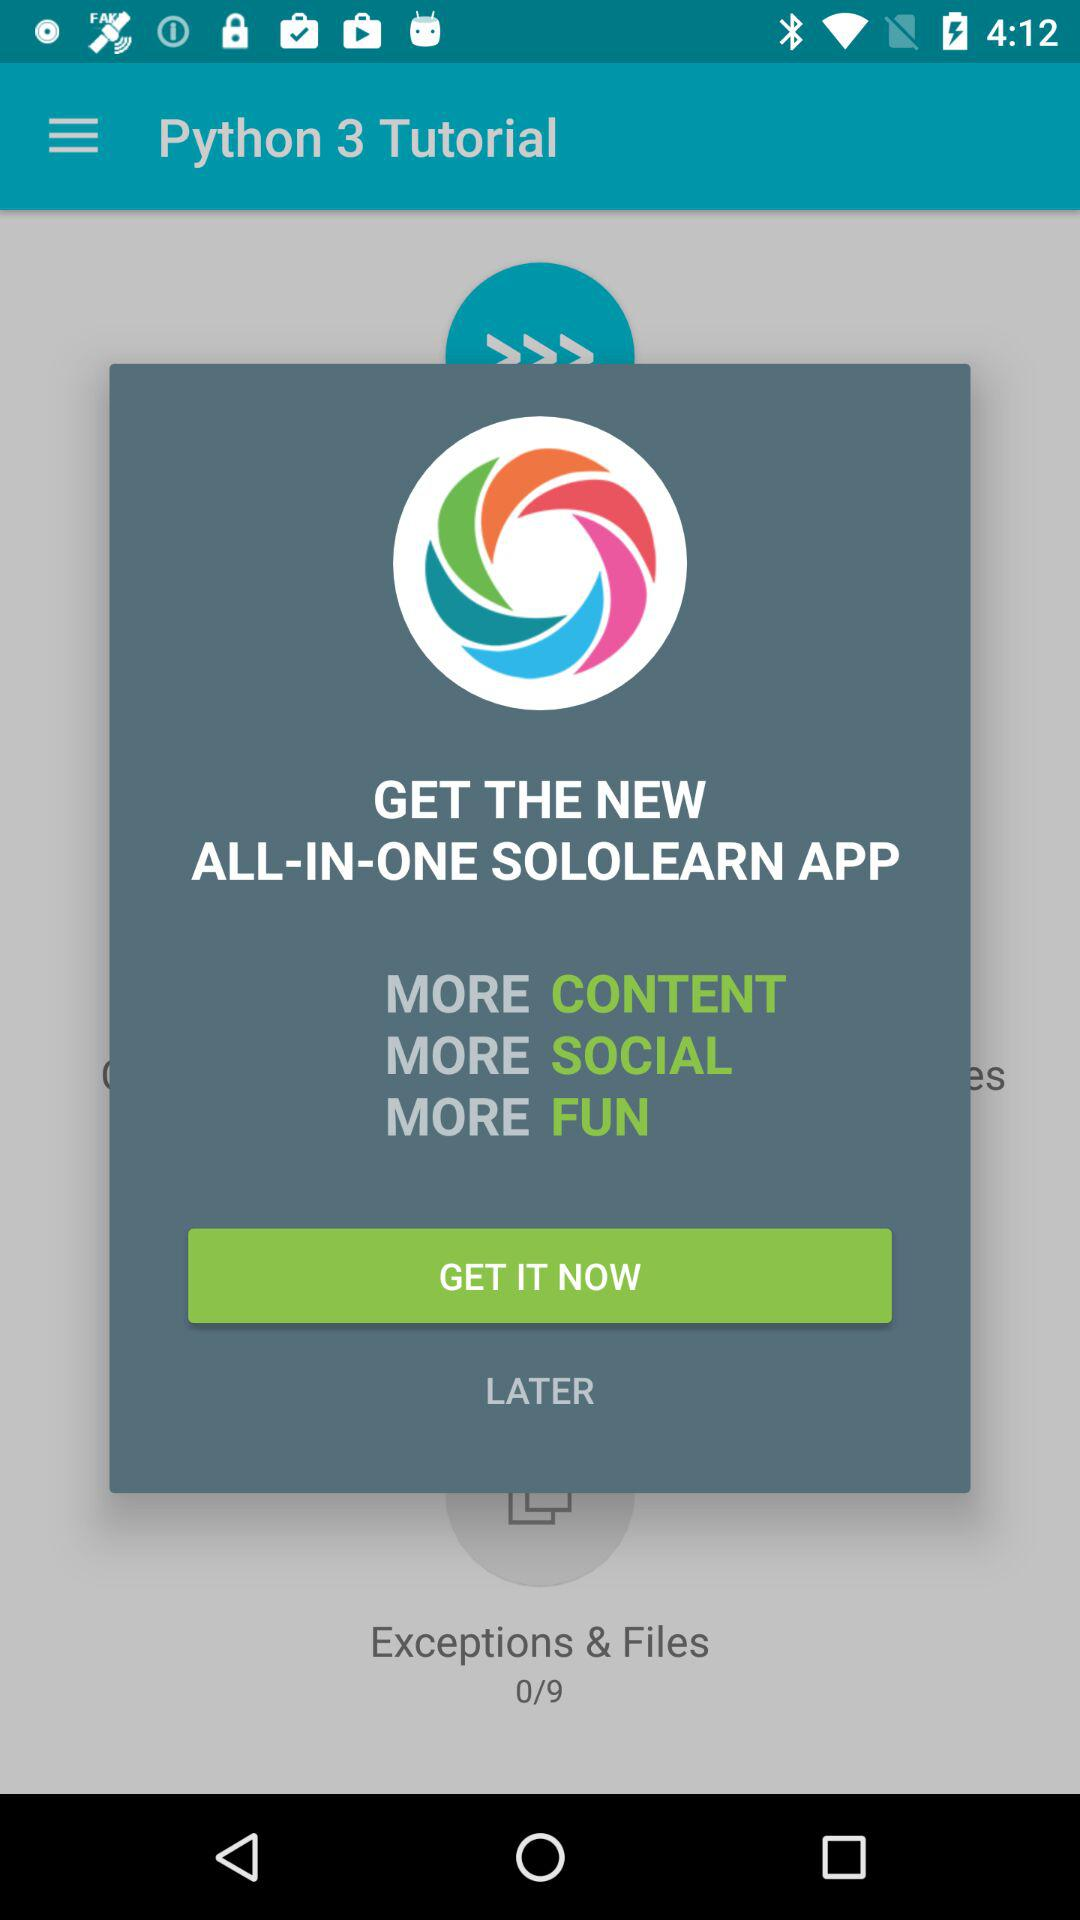How many steps are there in this lesson?
Answer the question using a single word or phrase. 9 